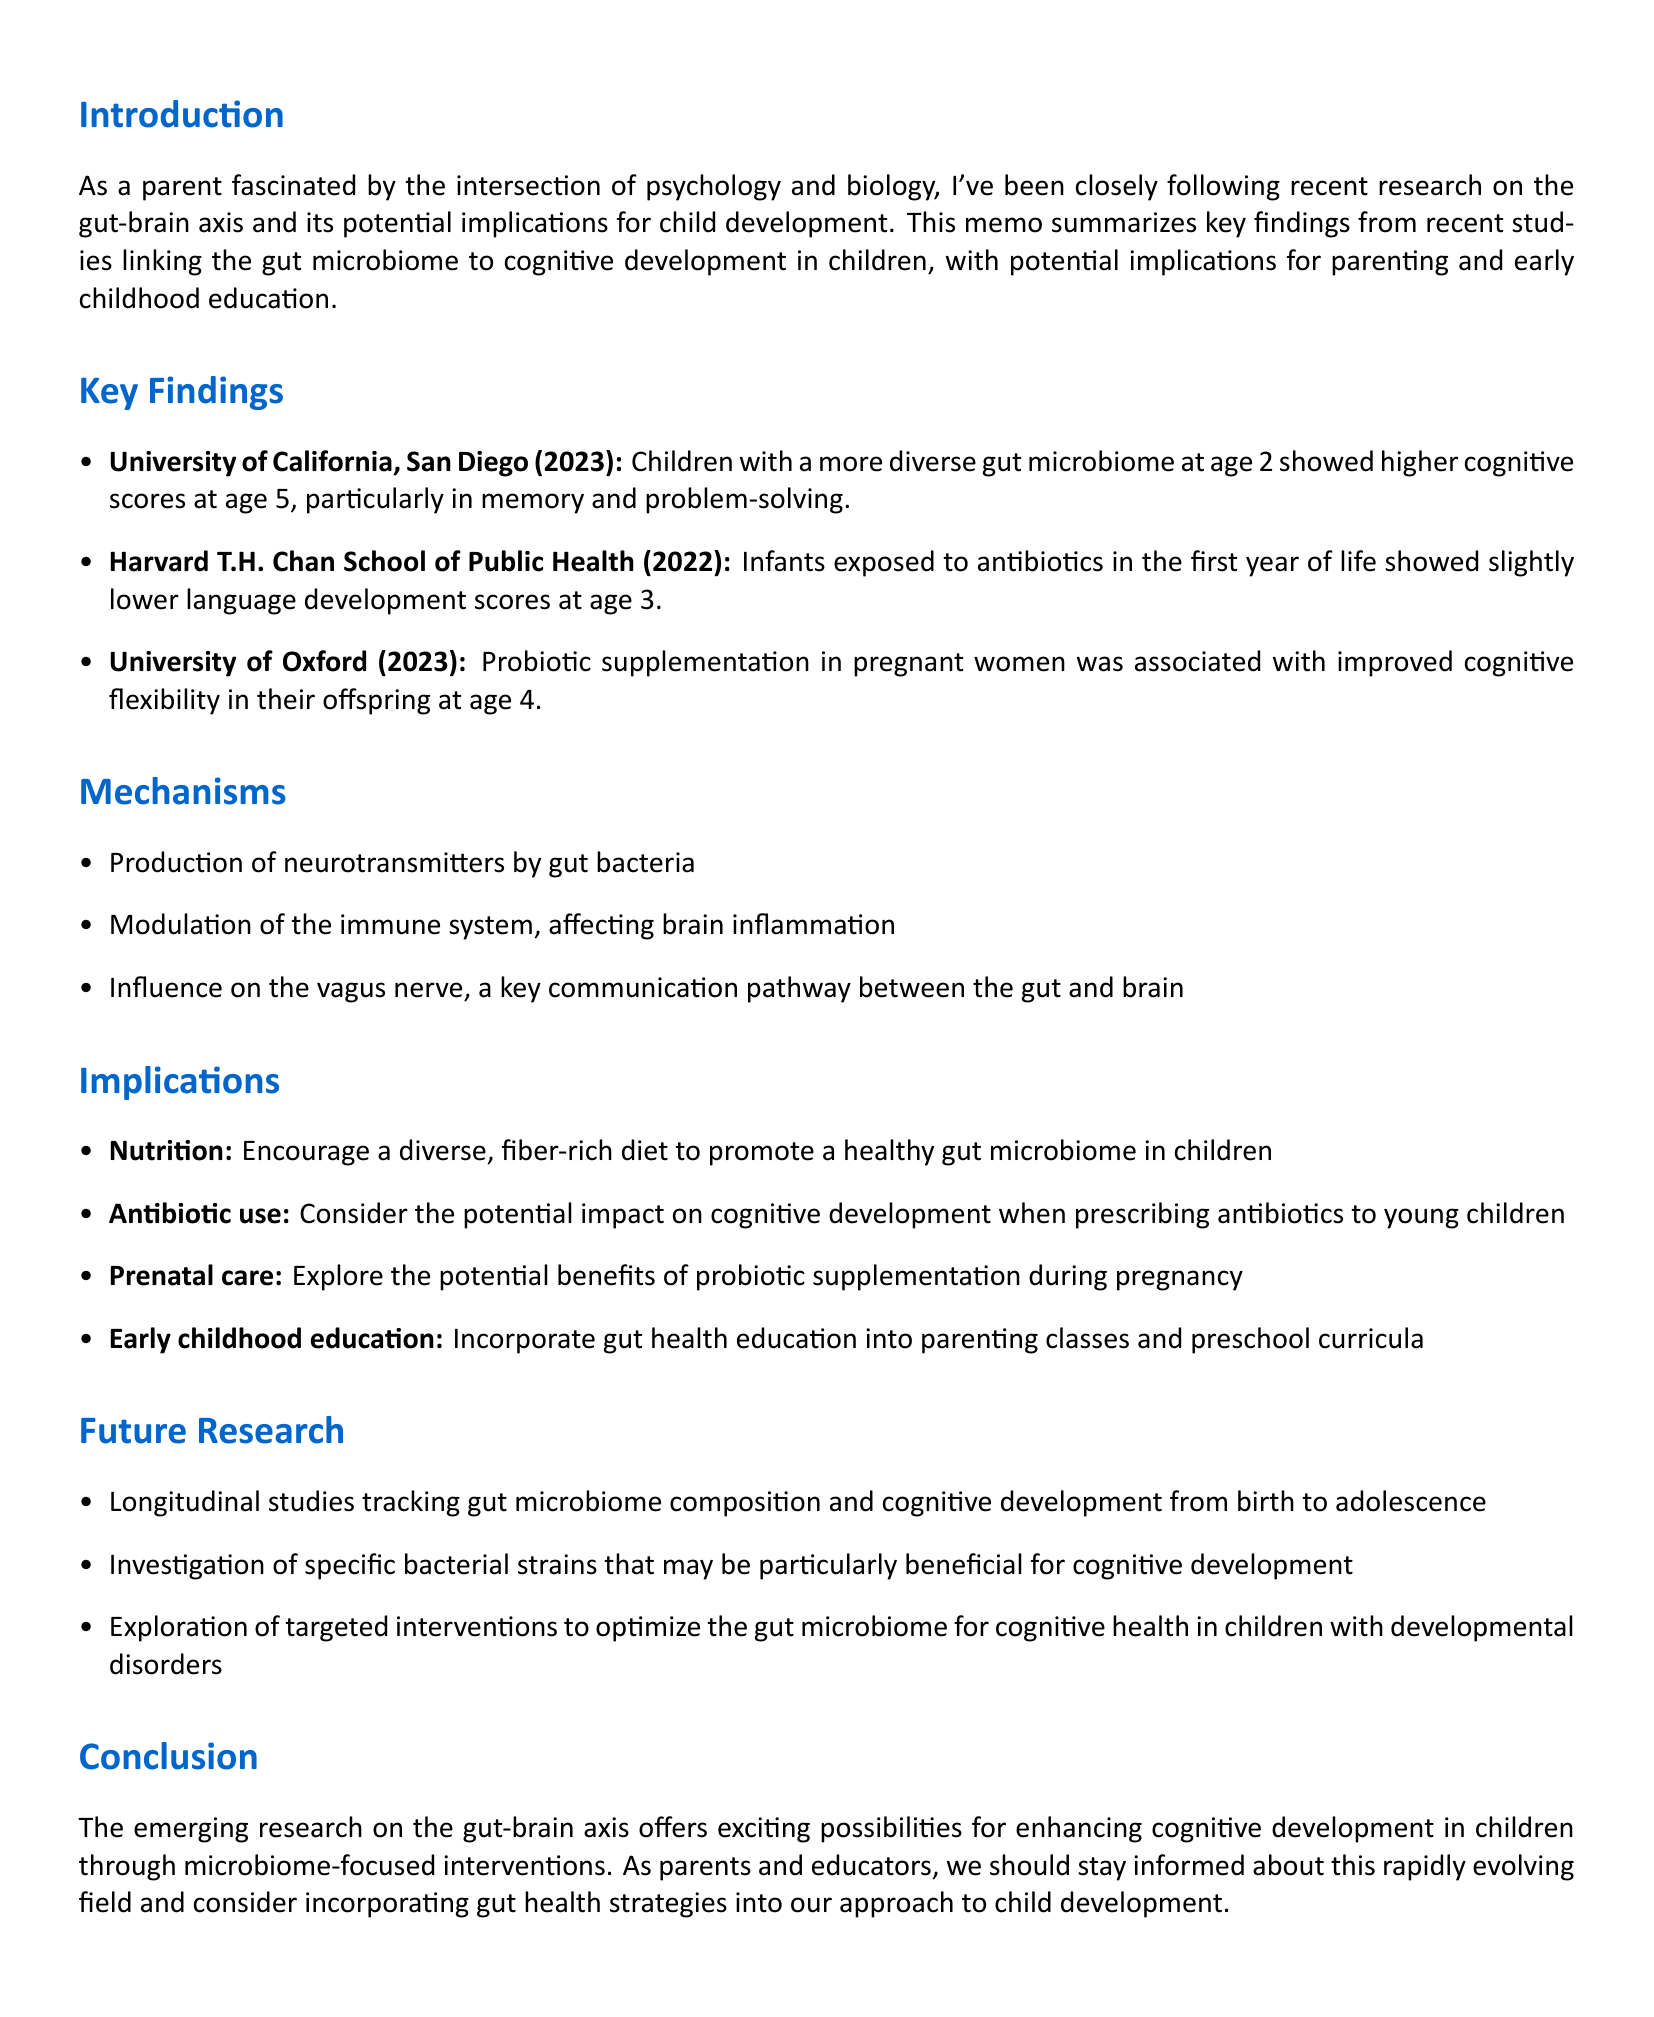what is the title of the memo? The title of the memo is found at the top and summarizes the document's main theme.
Answer: Recent Findings: Gut Microbiome's Impact on Childhood Cognitive Development who conducted the study at the University of California, San Diego? This information details the researchers involved in the key findings related to the gut microbiome and cognitive development.
Answer: Dr. Emily Chen and Dr. Michael Rodriguez what year was the study published by the Harvard T.H. Chan School of Public Health? The publication year is noted in the key findings and relates to its relevance to the study's findings.
Answer: 2022 what is one mechanism by which gut bacteria influence cognitive development? The document lists several mechanisms through which gut bacteria can affect cognitive function.
Answer: Production of neurotransmitters by gut bacteria which nutrient-rich diet is recommended for children? This recommendation aims to promote gut health and is derived from the implications section of the memo.
Answer: A diverse, fiber-rich diet what age did children show higher cognitive scores if they had a diverse gut microbiome at age 2? The findings include specific ages when cognitive scores were assessed, reflecting the connection between gut health and cognitive development.
Answer: Age 5 what type of studies do the future research suggestions emphasize? This question assesses the direction of future research as detailed in the implications for ongoing investigation in this field.
Answer: Longitudinal studies what should be incorporated into parenting classes according to the memo? This refers to actionable recommendations for educators as per the implications section of the document.
Answer: Gut health education what is the main call to action for parents and educators? This encapsulates the conclusion of the memo and summarizes the urgency of incorporating findings into practice.
Answer: Stay informed about this rapidly evolving field 